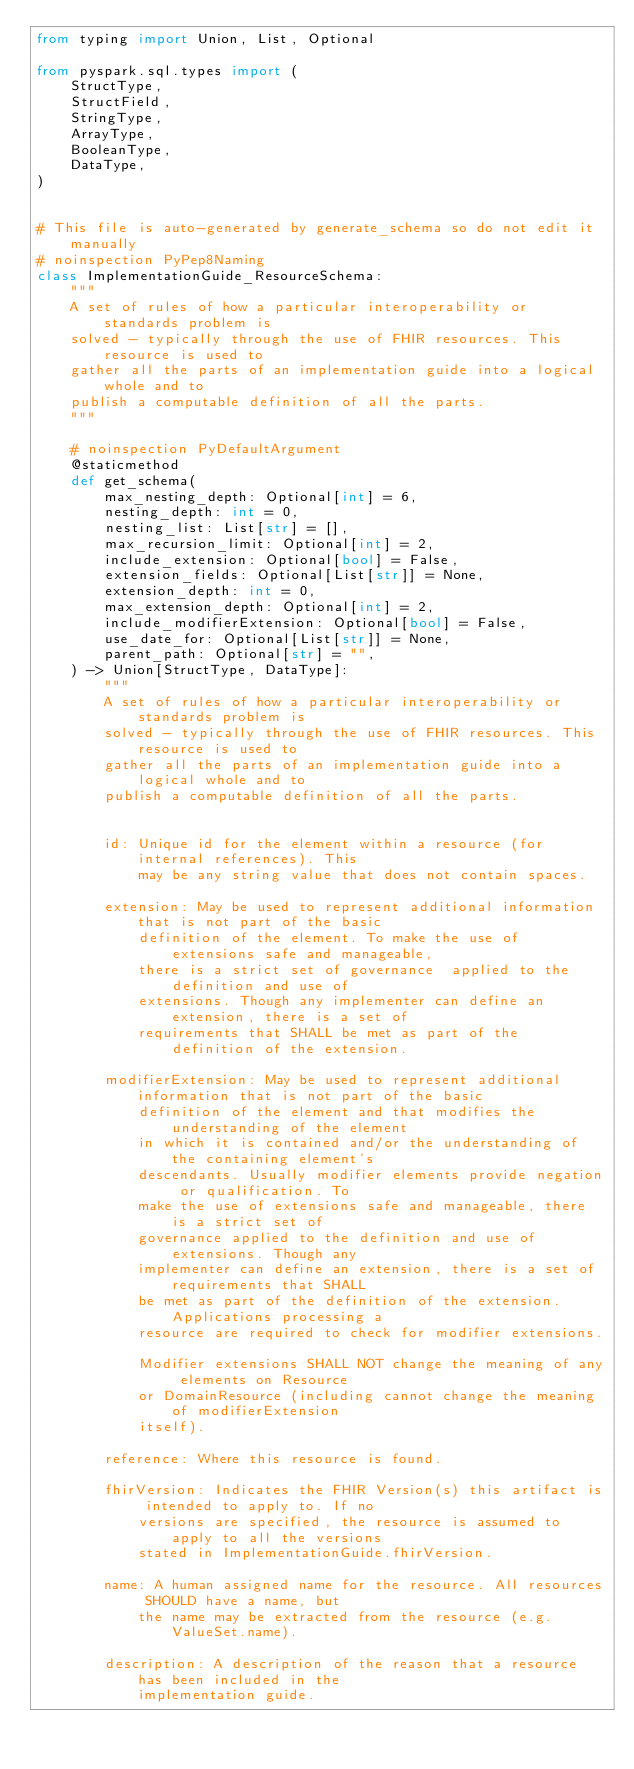Convert code to text. <code><loc_0><loc_0><loc_500><loc_500><_Python_>from typing import Union, List, Optional

from pyspark.sql.types import (
    StructType,
    StructField,
    StringType,
    ArrayType,
    BooleanType,
    DataType,
)


# This file is auto-generated by generate_schema so do not edit it manually
# noinspection PyPep8Naming
class ImplementationGuide_ResourceSchema:
    """
    A set of rules of how a particular interoperability or standards problem is
    solved - typically through the use of FHIR resources. This resource is used to
    gather all the parts of an implementation guide into a logical whole and to
    publish a computable definition of all the parts.
    """

    # noinspection PyDefaultArgument
    @staticmethod
    def get_schema(
        max_nesting_depth: Optional[int] = 6,
        nesting_depth: int = 0,
        nesting_list: List[str] = [],
        max_recursion_limit: Optional[int] = 2,
        include_extension: Optional[bool] = False,
        extension_fields: Optional[List[str]] = None,
        extension_depth: int = 0,
        max_extension_depth: Optional[int] = 2,
        include_modifierExtension: Optional[bool] = False,
        use_date_for: Optional[List[str]] = None,
        parent_path: Optional[str] = "",
    ) -> Union[StructType, DataType]:
        """
        A set of rules of how a particular interoperability or standards problem is
        solved - typically through the use of FHIR resources. This resource is used to
        gather all the parts of an implementation guide into a logical whole and to
        publish a computable definition of all the parts.


        id: Unique id for the element within a resource (for internal references). This
            may be any string value that does not contain spaces.

        extension: May be used to represent additional information that is not part of the basic
            definition of the element. To make the use of extensions safe and manageable,
            there is a strict set of governance  applied to the definition and use of
            extensions. Though any implementer can define an extension, there is a set of
            requirements that SHALL be met as part of the definition of the extension.

        modifierExtension: May be used to represent additional information that is not part of the basic
            definition of the element and that modifies the understanding of the element
            in which it is contained and/or the understanding of the containing element's
            descendants. Usually modifier elements provide negation or qualification. To
            make the use of extensions safe and manageable, there is a strict set of
            governance applied to the definition and use of extensions. Though any
            implementer can define an extension, there is a set of requirements that SHALL
            be met as part of the definition of the extension. Applications processing a
            resource are required to check for modifier extensions.

            Modifier extensions SHALL NOT change the meaning of any elements on Resource
            or DomainResource (including cannot change the meaning of modifierExtension
            itself).

        reference: Where this resource is found.

        fhirVersion: Indicates the FHIR Version(s) this artifact is intended to apply to. If no
            versions are specified, the resource is assumed to apply to all the versions
            stated in ImplementationGuide.fhirVersion.

        name: A human assigned name for the resource. All resources SHOULD have a name, but
            the name may be extracted from the resource (e.g. ValueSet.name).

        description: A description of the reason that a resource has been included in the
            implementation guide.
</code> 